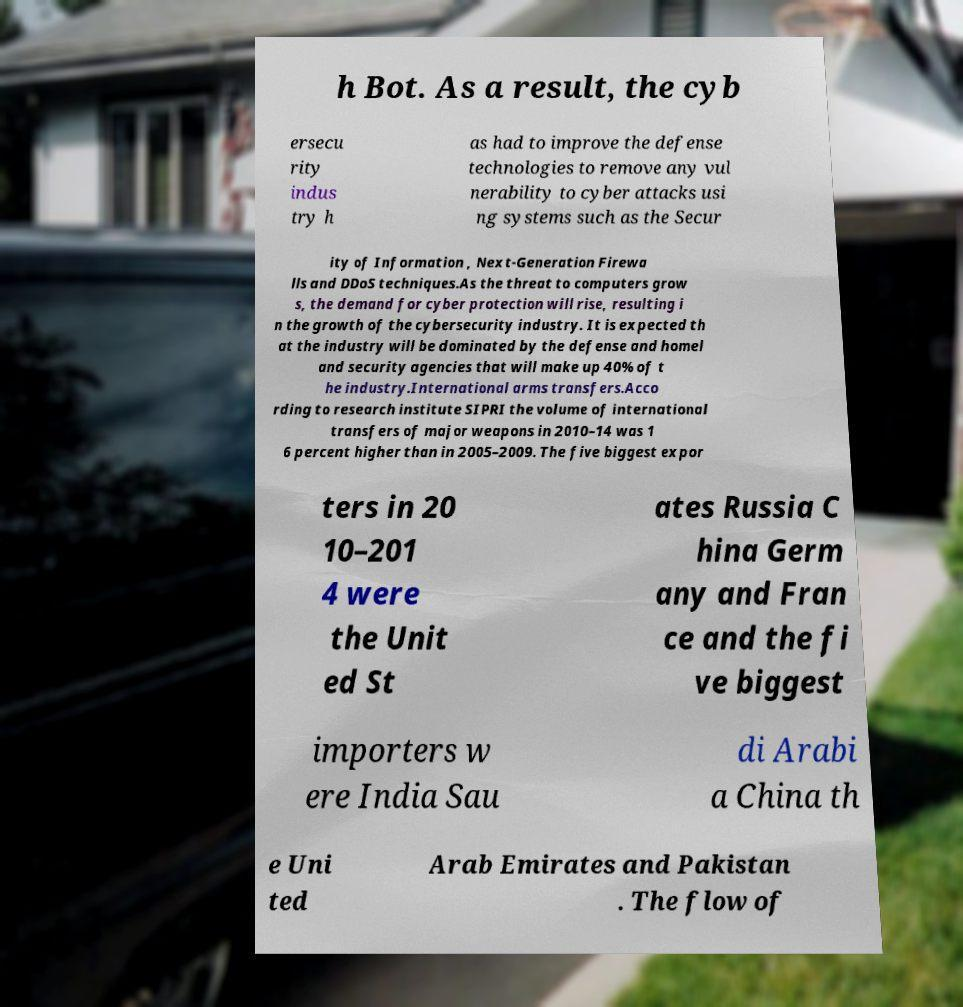Please read and relay the text visible in this image. What does it say? h Bot. As a result, the cyb ersecu rity indus try h as had to improve the defense technologies to remove any vul nerability to cyber attacks usi ng systems such as the Secur ity of Information , Next-Generation Firewa lls and DDoS techniques.As the threat to computers grow s, the demand for cyber protection will rise, resulting i n the growth of the cybersecurity industry. It is expected th at the industry will be dominated by the defense and homel and security agencies that will make up 40% of t he industry.International arms transfers.Acco rding to research institute SIPRI the volume of international transfers of major weapons in 2010–14 was 1 6 percent higher than in 2005–2009. The five biggest expor ters in 20 10–201 4 were the Unit ed St ates Russia C hina Germ any and Fran ce and the fi ve biggest importers w ere India Sau di Arabi a China th e Uni ted Arab Emirates and Pakistan . The flow of 